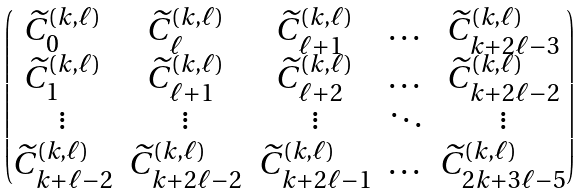Convert formula to latex. <formula><loc_0><loc_0><loc_500><loc_500>\begin{pmatrix} \widetilde { C } _ { 0 } ^ { ( k , \ell ) } & \widetilde { C } _ { \ell } ^ { ( k , \ell ) } & \widetilde { C } _ { \ell + 1 } ^ { ( k , \ell ) } & \dots & \widetilde { C } _ { k + 2 \ell - 3 } ^ { ( k , \ell ) } \\ \widetilde { C } _ { 1 } ^ { ( k , \ell ) } & \widetilde { C } _ { \ell + 1 } ^ { ( k , \ell ) } & \widetilde { C } _ { \ell + 2 } ^ { ( k , \ell ) } & \dots & \widetilde { C } _ { k + 2 \ell - 2 } ^ { ( k , \ell ) } \\ \vdots & \vdots & \vdots & \ddots & \vdots \\ \widetilde { C } _ { k + \ell - 2 } ^ { ( k , \ell ) } & \widetilde { C } _ { k + 2 \ell - 2 } ^ { ( k , \ell ) } & \widetilde { C } _ { k + 2 \ell - 1 } ^ { ( k , \ell ) } & \dots & \widetilde { C } _ { 2 k + 3 \ell - 5 } ^ { ( k , \ell ) } \end{pmatrix}</formula> 